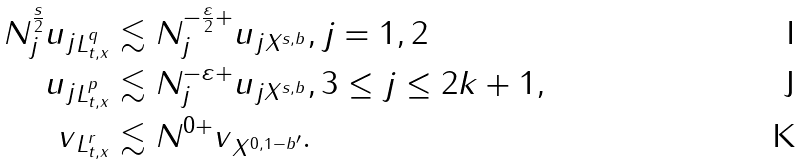Convert formula to latex. <formula><loc_0><loc_0><loc_500><loc_500>N _ { j } ^ { \frac { s } { 2 } } \| u _ { j } \| _ { L ^ { q } _ { t , x } } & \lesssim N _ { j } ^ { - \frac { \varepsilon } { 2 } + } \| u _ { j } \| _ { X ^ { s , b } } , j = 1 , 2 \\ \| u _ { j } \| _ { L ^ { p } _ { t , x } } & \lesssim N _ { j } ^ { - \varepsilon + } \| u _ { j } \| _ { X ^ { s , b } } , 3 \leq j \leq 2 k + 1 , \\ \| v \| _ { L ^ { r } _ { t , x } } & \lesssim N ^ { 0 + } \| v \| _ { X ^ { 0 , 1 - b ^ { \prime } } } .</formula> 